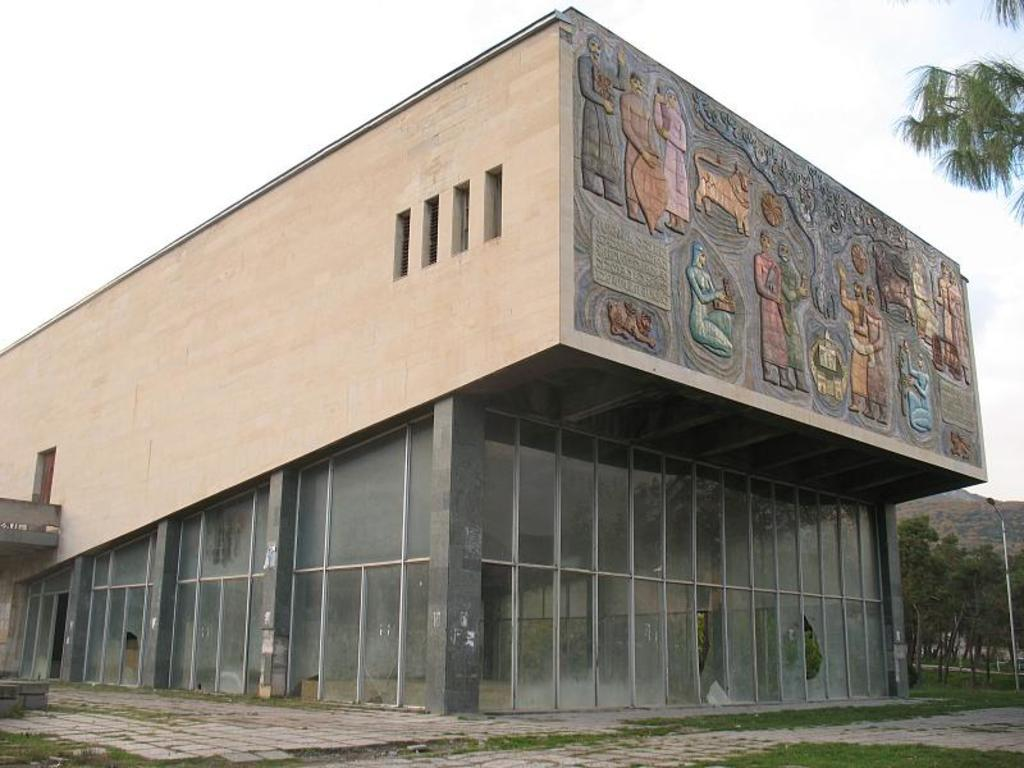What type of structure is visible in the image? There is a building in the image. What else can be seen in the background of the image? There is a pole and trees in the background of the image. What is visible at the top of the image? The sky is visible at the top of the image. What color is the coal being used by the hands in the image? There are no hands or coal present in the image. 